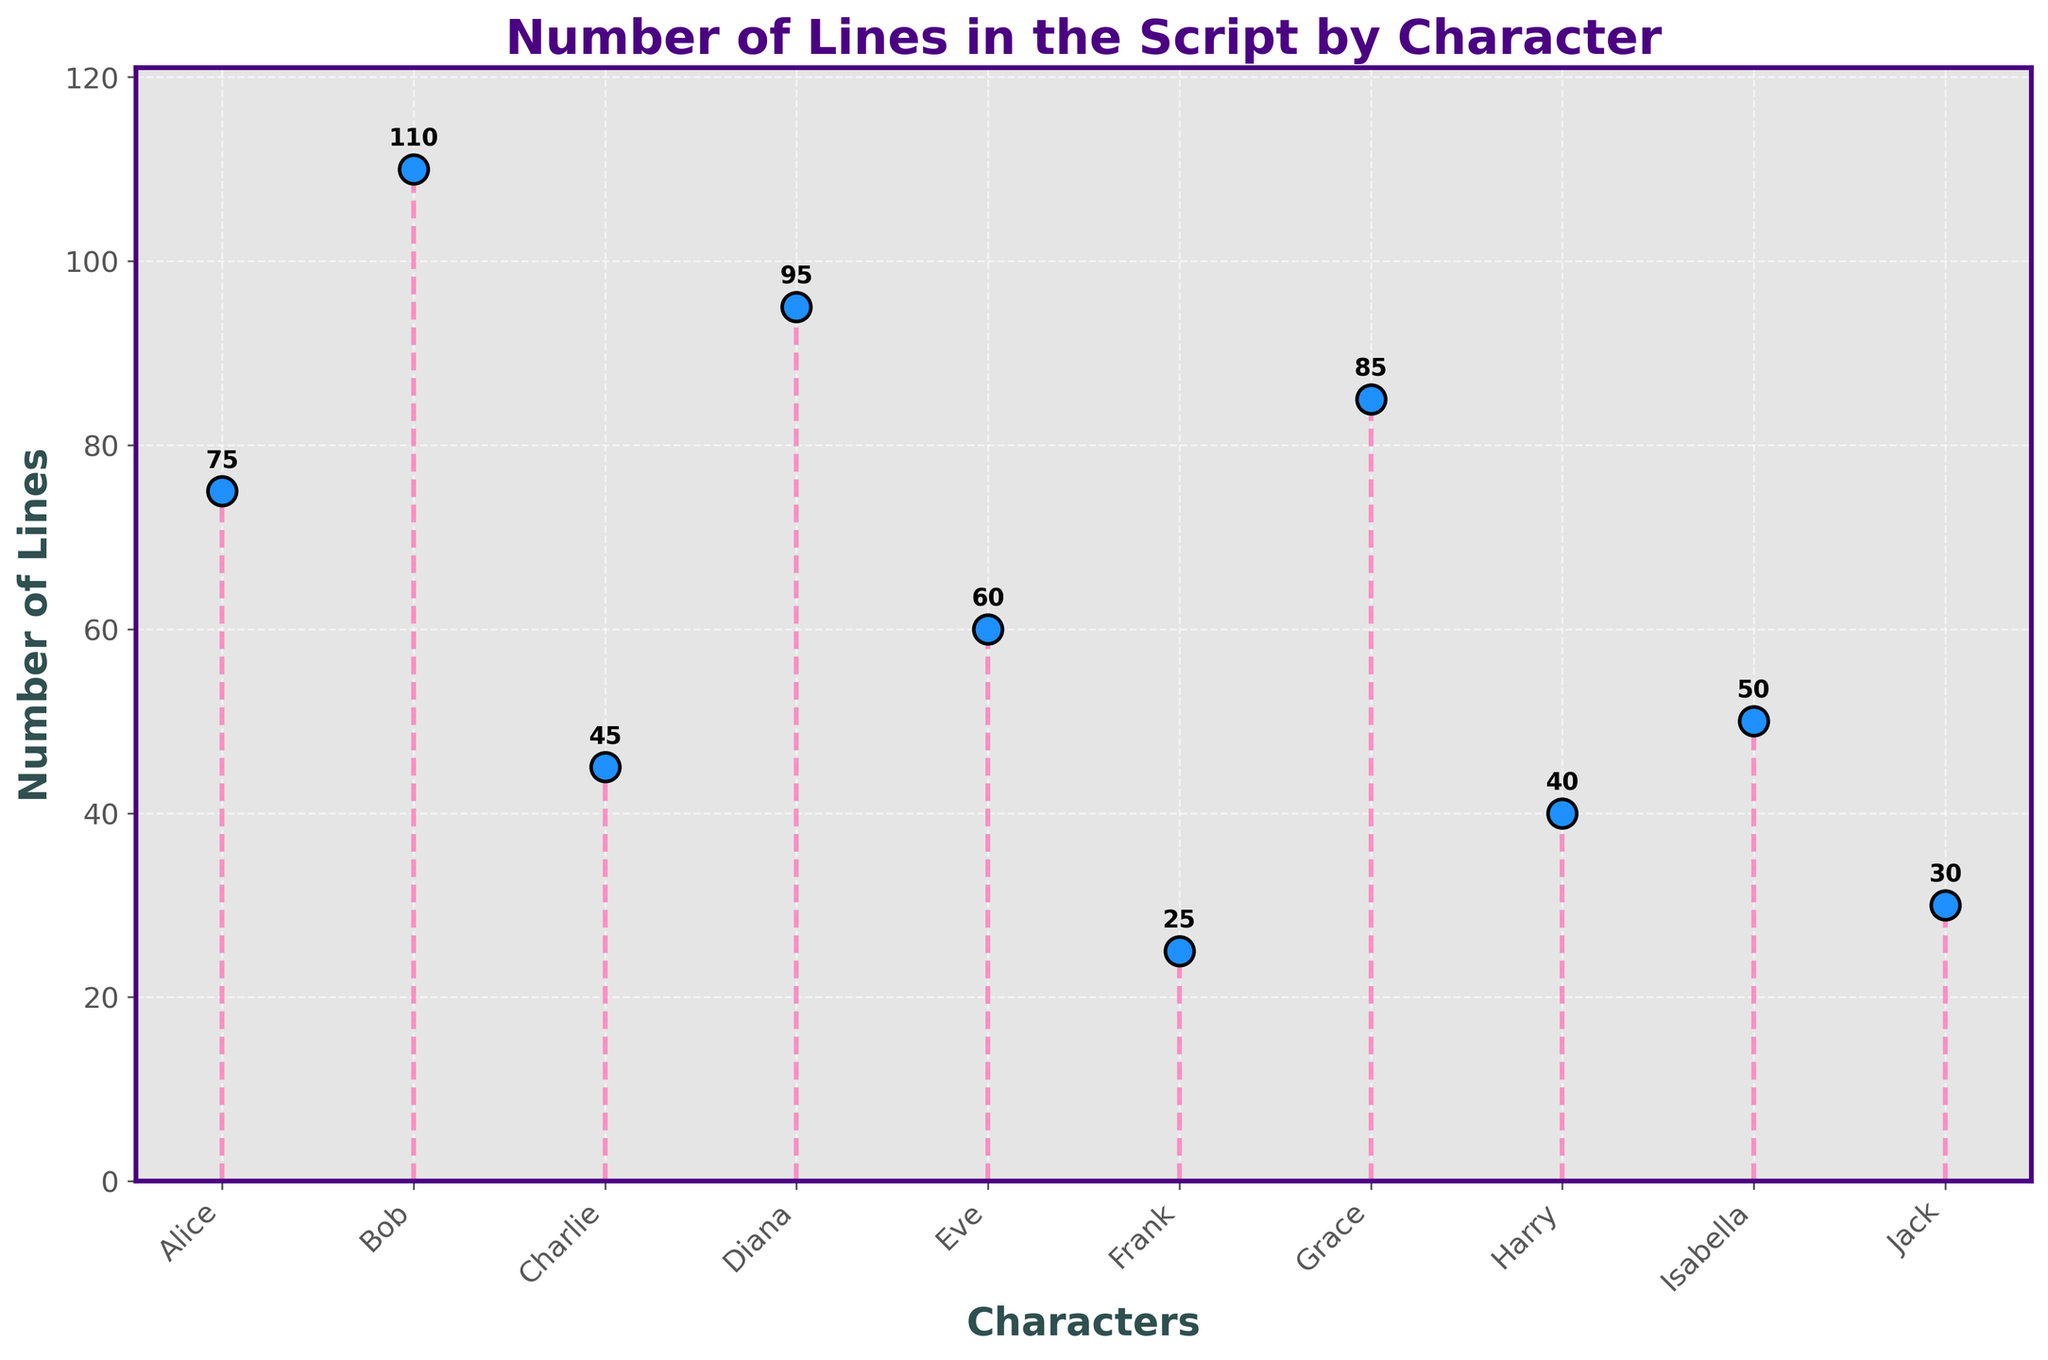What is the total number of characters shown in the plot? Count the data points represented on the x-axis, each labeled with a character name. There are 10 character names shown.
Answer: 10 Which character has the highest number of lines? Observe the y-values associated with each character on the x-axis. Bob has the highest y-value at 110 lines.
Answer: Bob What is the range of the number of lines? Calculate the range by subtracting the smallest y-value (Frank with 25 lines) from the largest y-value (Bob with 110 lines). 110 - 25 = 85
Answer: 85 What is the total number of lines spoken by all characters? Sum the y-values for all characters: 75 + 110 + 45 + 95 + 60 + 25 + 85 + 40 + 50 + 30 = 615
Answer: 615 Which characters have fewer lines than Alice? Compare the y-values for each character with Alice's 75 lines. Characters with fewer lines are Charlie (45), Frank (25), Harry (40), Isabella (50), and Jack (30).
Answer: Charlie, Frank, Harry, Isabella, Jack What is the difference in the number of lines between Diana and Eve? Subtract Eve's lines (60) from Diana's lines (95). 95 - 60 = 35
Answer: 35 What is the average number of lines per character? Divide the total number of lines (615) by the number of characters (10). 615 / 10 = 61.5
Answer: 61.5 Which character has the third highest number of lines? Arrange the characters by y-values in descending order: Bob (110), Diana (95), Alice (75). Alice has the third highest number of lines.
Answer: Alice What percentage of the total lines does Frank have? Divide Frank's lines (25) by the total number of lines (615) and multiply by 100. (25 / 615) * 100 ≈ 4.07
Answer: 4.07% Which character has more lines, Eve or Grace? Compare the y-values for Eve (60) and Grace (85). Grace has more lines than Eve.
Answer: Grace 